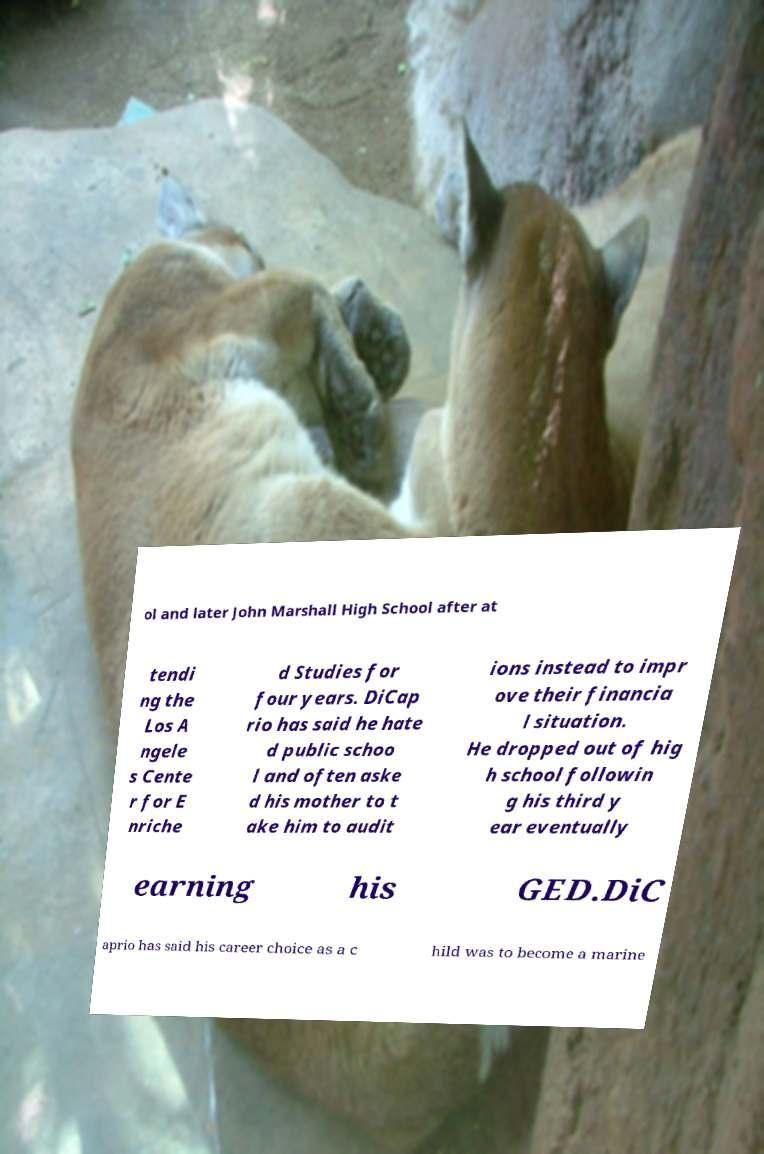What messages or text are displayed in this image? I need them in a readable, typed format. ol and later John Marshall High School after at tendi ng the Los A ngele s Cente r for E nriche d Studies for four years. DiCap rio has said he hate d public schoo l and often aske d his mother to t ake him to audit ions instead to impr ove their financia l situation. He dropped out of hig h school followin g his third y ear eventually earning his GED.DiC aprio has said his career choice as a c hild was to become a marine 